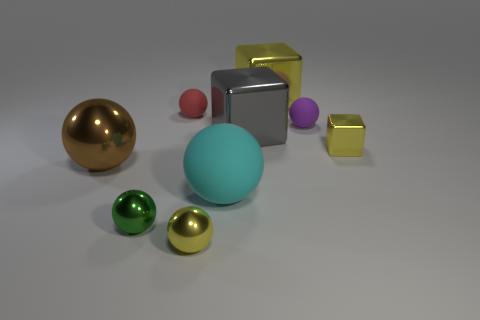How would you describe the atmosphere or mood of this scene? The scene conveys a stillness that evokes a sense of contemplation or study. The soft lighting and minimalistic arrangement of the objects create an atmosphere that's both peaceful and harmonious, with the variety of colors and shapes adding subtle visual interest. 